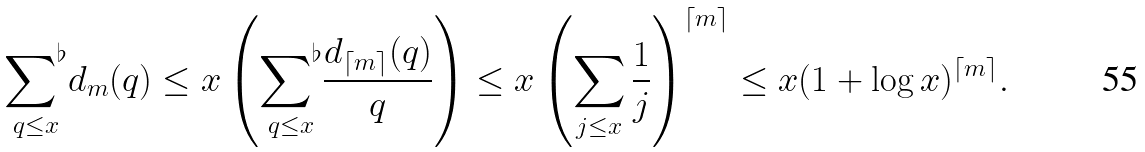Convert formula to latex. <formula><loc_0><loc_0><loc_500><loc_500>\underset { q \leq x } { \sum \nolimits ^ { \flat } } d _ { m } ( q ) \leq x \left ( \underset { q \leq x } { \sum \nolimits ^ { \flat } } \frac { d _ { \lceil m \rceil } ( q ) } { q } \right ) \leq x \left ( \sum _ { j \leq x } \frac { 1 } { j } \right ) ^ { \lceil m \rceil } \leq x ( 1 + \log x ) ^ { \lceil m \rceil } .</formula> 